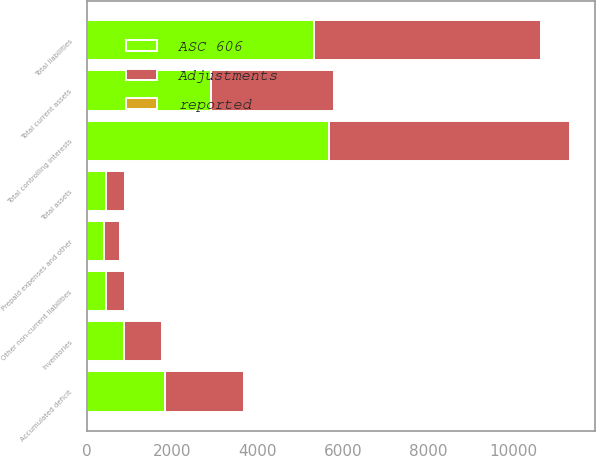<chart> <loc_0><loc_0><loc_500><loc_500><stacked_bar_chart><ecel><fcel>Inventories<fcel>Prepaid expenses and other<fcel>Total current assets<fcel>Total assets<fcel>Other non-current liabilities<fcel>Total liabilities<fcel>Accumulated deficit<fcel>Total controlling interests<nl><fcel>ASC 606<fcel>878<fcel>400<fcel>2902.2<fcel>443.35<fcel>443.4<fcel>5315.3<fcel>1838.3<fcel>5668<nl><fcel>reported<fcel>17.2<fcel>25.5<fcel>8.3<fcel>8.3<fcel>0.1<fcel>0.1<fcel>8.2<fcel>8.2<nl><fcel>Adjustments<fcel>895.2<fcel>374.5<fcel>2893.9<fcel>443.35<fcel>443.3<fcel>5315.2<fcel>1846.5<fcel>5659.8<nl></chart> 